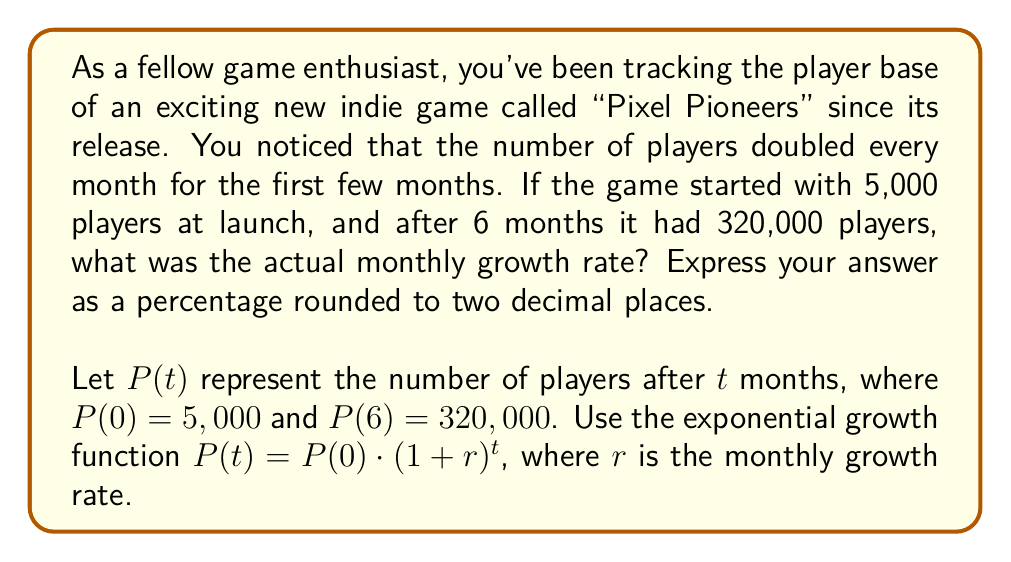Could you help me with this problem? To solve this problem, we'll use the exponential growth function and the given information:

1) We know that $P(0) = 5,000$ and $P(6) = 320,000$.
2) Let's plug these into the exponential growth function:

   $P(6) = P(0) \cdot (1+r)^6$

3) Substitute the known values:

   $320,000 = 5,000 \cdot (1+r)^6$

4) Divide both sides by 5,000:

   $64 = (1+r)^6$

5) Take the 6th root of both sides:

   $\sqrt[6]{64} = 1+r$

6) Simplify the left side:

   $2 = 1+r$

7) Subtract 1 from both sides:

   $1 = r$

8) Convert to a percentage:

   $r = 1 = 100\%$

Therefore, the monthly growth rate was 100%.

To verify:
$5,000 \cdot (1+1)^6 = 5,000 \cdot 2^6 = 5,000 \cdot 64 = 320,000$

This confirms our calculation.
Answer: The monthly growth rate was 100.00%. 